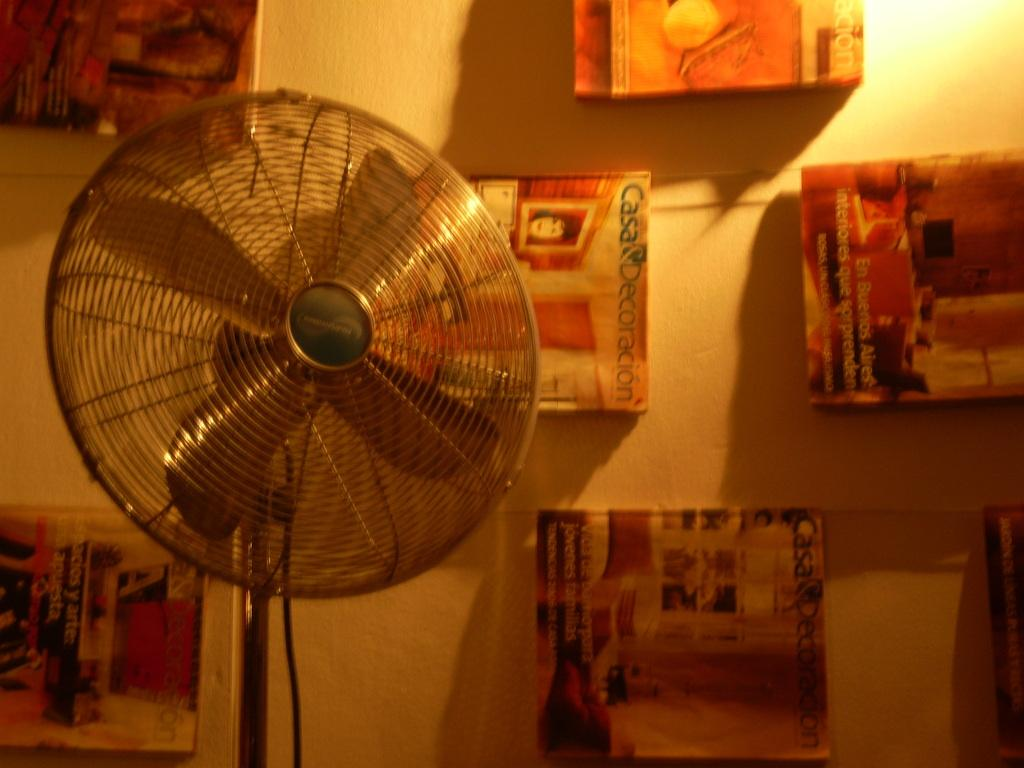<image>
Offer a succinct explanation of the picture presented. A picture with CASA is to the right of the fan. 